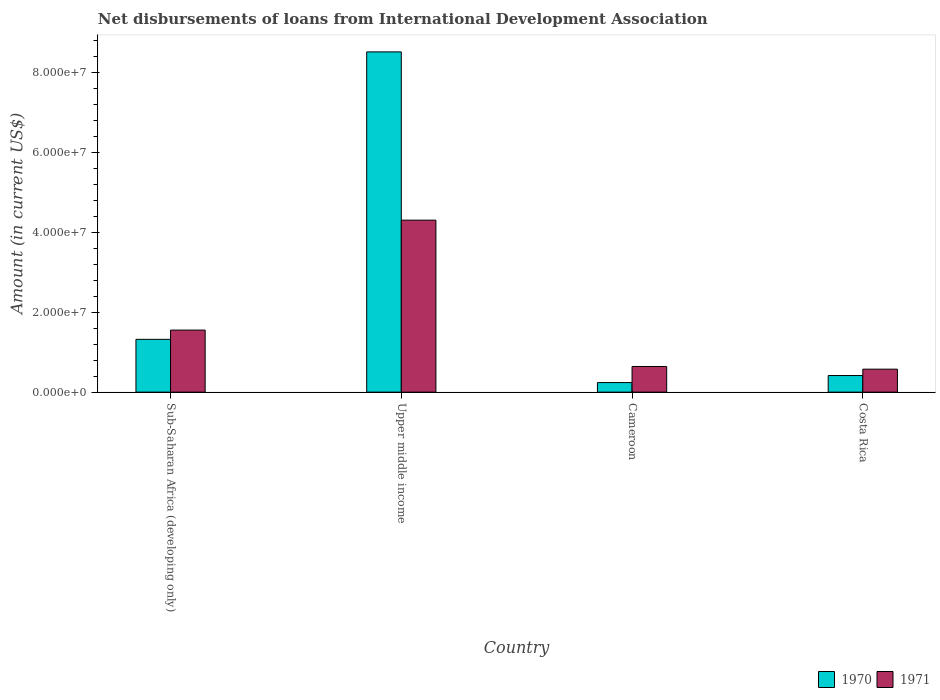How many different coloured bars are there?
Provide a succinct answer. 2. Are the number of bars per tick equal to the number of legend labels?
Your response must be concise. Yes. Are the number of bars on each tick of the X-axis equal?
Ensure brevity in your answer.  Yes. How many bars are there on the 2nd tick from the right?
Give a very brief answer. 2. What is the label of the 1st group of bars from the left?
Provide a succinct answer. Sub-Saharan Africa (developing only). What is the amount of loans disbursed in 1970 in Costa Rica?
Keep it short and to the point. 4.15e+06. Across all countries, what is the maximum amount of loans disbursed in 1971?
Ensure brevity in your answer.  4.30e+07. Across all countries, what is the minimum amount of loans disbursed in 1971?
Offer a very short reply. 5.74e+06. In which country was the amount of loans disbursed in 1971 maximum?
Make the answer very short. Upper middle income. In which country was the amount of loans disbursed in 1970 minimum?
Your response must be concise. Cameroon. What is the total amount of loans disbursed in 1971 in the graph?
Provide a short and direct response. 7.07e+07. What is the difference between the amount of loans disbursed in 1970 in Costa Rica and that in Upper middle income?
Provide a succinct answer. -8.09e+07. What is the difference between the amount of loans disbursed in 1970 in Cameroon and the amount of loans disbursed in 1971 in Sub-Saharan Africa (developing only)?
Your answer should be compact. -1.31e+07. What is the average amount of loans disbursed in 1970 per country?
Offer a very short reply. 2.62e+07. What is the difference between the amount of loans disbursed of/in 1971 and amount of loans disbursed of/in 1970 in Costa Rica?
Provide a short and direct response. 1.59e+06. In how many countries, is the amount of loans disbursed in 1970 greater than 60000000 US$?
Ensure brevity in your answer.  1. What is the ratio of the amount of loans disbursed in 1971 in Cameroon to that in Sub-Saharan Africa (developing only)?
Give a very brief answer. 0.41. What is the difference between the highest and the second highest amount of loans disbursed in 1970?
Give a very brief answer. 7.19e+07. What is the difference between the highest and the lowest amount of loans disbursed in 1970?
Your answer should be very brief. 8.27e+07. Is the sum of the amount of loans disbursed in 1970 in Cameroon and Sub-Saharan Africa (developing only) greater than the maximum amount of loans disbursed in 1971 across all countries?
Make the answer very short. No. What does the 2nd bar from the right in Cameroon represents?
Your answer should be compact. 1970. Where does the legend appear in the graph?
Offer a very short reply. Bottom right. How many legend labels are there?
Keep it short and to the point. 2. What is the title of the graph?
Your answer should be compact. Net disbursements of loans from International Development Association. What is the label or title of the Y-axis?
Provide a succinct answer. Amount (in current US$). What is the Amount (in current US$) of 1970 in Sub-Saharan Africa (developing only)?
Your response must be concise. 1.32e+07. What is the Amount (in current US$) of 1971 in Sub-Saharan Africa (developing only)?
Your answer should be very brief. 1.55e+07. What is the Amount (in current US$) of 1970 in Upper middle income?
Offer a very short reply. 8.51e+07. What is the Amount (in current US$) of 1971 in Upper middle income?
Provide a short and direct response. 4.30e+07. What is the Amount (in current US$) in 1970 in Cameroon?
Offer a terse response. 2.40e+06. What is the Amount (in current US$) of 1971 in Cameroon?
Provide a succinct answer. 6.42e+06. What is the Amount (in current US$) in 1970 in Costa Rica?
Ensure brevity in your answer.  4.15e+06. What is the Amount (in current US$) in 1971 in Costa Rica?
Your answer should be very brief. 5.74e+06. Across all countries, what is the maximum Amount (in current US$) in 1970?
Keep it short and to the point. 8.51e+07. Across all countries, what is the maximum Amount (in current US$) of 1971?
Your response must be concise. 4.30e+07. Across all countries, what is the minimum Amount (in current US$) in 1970?
Make the answer very short. 2.40e+06. Across all countries, what is the minimum Amount (in current US$) in 1971?
Offer a very short reply. 5.74e+06. What is the total Amount (in current US$) of 1970 in the graph?
Make the answer very short. 1.05e+08. What is the total Amount (in current US$) in 1971 in the graph?
Give a very brief answer. 7.07e+07. What is the difference between the Amount (in current US$) in 1970 in Sub-Saharan Africa (developing only) and that in Upper middle income?
Give a very brief answer. -7.19e+07. What is the difference between the Amount (in current US$) of 1971 in Sub-Saharan Africa (developing only) and that in Upper middle income?
Make the answer very short. -2.75e+07. What is the difference between the Amount (in current US$) in 1970 in Sub-Saharan Africa (developing only) and that in Cameroon?
Your response must be concise. 1.08e+07. What is the difference between the Amount (in current US$) of 1971 in Sub-Saharan Africa (developing only) and that in Cameroon?
Your answer should be very brief. 9.10e+06. What is the difference between the Amount (in current US$) in 1970 in Sub-Saharan Africa (developing only) and that in Costa Rica?
Make the answer very short. 9.05e+06. What is the difference between the Amount (in current US$) in 1971 in Sub-Saharan Africa (developing only) and that in Costa Rica?
Provide a succinct answer. 9.77e+06. What is the difference between the Amount (in current US$) in 1970 in Upper middle income and that in Cameroon?
Your answer should be compact. 8.27e+07. What is the difference between the Amount (in current US$) in 1971 in Upper middle income and that in Cameroon?
Your response must be concise. 3.66e+07. What is the difference between the Amount (in current US$) of 1970 in Upper middle income and that in Costa Rica?
Your answer should be very brief. 8.09e+07. What is the difference between the Amount (in current US$) in 1971 in Upper middle income and that in Costa Rica?
Provide a succinct answer. 3.73e+07. What is the difference between the Amount (in current US$) of 1970 in Cameroon and that in Costa Rica?
Provide a succinct answer. -1.76e+06. What is the difference between the Amount (in current US$) of 1971 in Cameroon and that in Costa Rica?
Ensure brevity in your answer.  6.75e+05. What is the difference between the Amount (in current US$) of 1970 in Sub-Saharan Africa (developing only) and the Amount (in current US$) of 1971 in Upper middle income?
Ensure brevity in your answer.  -2.98e+07. What is the difference between the Amount (in current US$) in 1970 in Sub-Saharan Africa (developing only) and the Amount (in current US$) in 1971 in Cameroon?
Your answer should be very brief. 6.78e+06. What is the difference between the Amount (in current US$) of 1970 in Sub-Saharan Africa (developing only) and the Amount (in current US$) of 1971 in Costa Rica?
Offer a very short reply. 7.46e+06. What is the difference between the Amount (in current US$) of 1970 in Upper middle income and the Amount (in current US$) of 1971 in Cameroon?
Your response must be concise. 7.86e+07. What is the difference between the Amount (in current US$) of 1970 in Upper middle income and the Amount (in current US$) of 1971 in Costa Rica?
Offer a terse response. 7.93e+07. What is the difference between the Amount (in current US$) in 1970 in Cameroon and the Amount (in current US$) in 1971 in Costa Rica?
Your response must be concise. -3.35e+06. What is the average Amount (in current US$) in 1970 per country?
Offer a very short reply. 2.62e+07. What is the average Amount (in current US$) in 1971 per country?
Your response must be concise. 1.77e+07. What is the difference between the Amount (in current US$) in 1970 and Amount (in current US$) in 1971 in Sub-Saharan Africa (developing only)?
Ensure brevity in your answer.  -2.31e+06. What is the difference between the Amount (in current US$) of 1970 and Amount (in current US$) of 1971 in Upper middle income?
Keep it short and to the point. 4.21e+07. What is the difference between the Amount (in current US$) of 1970 and Amount (in current US$) of 1971 in Cameroon?
Your answer should be very brief. -4.02e+06. What is the difference between the Amount (in current US$) of 1970 and Amount (in current US$) of 1971 in Costa Rica?
Your answer should be compact. -1.59e+06. What is the ratio of the Amount (in current US$) of 1970 in Sub-Saharan Africa (developing only) to that in Upper middle income?
Your answer should be very brief. 0.16. What is the ratio of the Amount (in current US$) in 1971 in Sub-Saharan Africa (developing only) to that in Upper middle income?
Make the answer very short. 0.36. What is the ratio of the Amount (in current US$) in 1970 in Sub-Saharan Africa (developing only) to that in Cameroon?
Ensure brevity in your answer.  5.51. What is the ratio of the Amount (in current US$) of 1971 in Sub-Saharan Africa (developing only) to that in Cameroon?
Ensure brevity in your answer.  2.42. What is the ratio of the Amount (in current US$) in 1970 in Sub-Saharan Africa (developing only) to that in Costa Rica?
Give a very brief answer. 3.18. What is the ratio of the Amount (in current US$) of 1971 in Sub-Saharan Africa (developing only) to that in Costa Rica?
Provide a succinct answer. 2.7. What is the ratio of the Amount (in current US$) in 1970 in Upper middle income to that in Cameroon?
Offer a very short reply. 35.5. What is the ratio of the Amount (in current US$) of 1971 in Upper middle income to that in Cameroon?
Make the answer very short. 6.7. What is the ratio of the Amount (in current US$) in 1970 in Upper middle income to that in Costa Rica?
Offer a terse response. 20.48. What is the ratio of the Amount (in current US$) in 1971 in Upper middle income to that in Costa Rica?
Offer a very short reply. 7.49. What is the ratio of the Amount (in current US$) of 1970 in Cameroon to that in Costa Rica?
Make the answer very short. 0.58. What is the ratio of the Amount (in current US$) in 1971 in Cameroon to that in Costa Rica?
Offer a terse response. 1.12. What is the difference between the highest and the second highest Amount (in current US$) of 1970?
Your answer should be very brief. 7.19e+07. What is the difference between the highest and the second highest Amount (in current US$) in 1971?
Your answer should be very brief. 2.75e+07. What is the difference between the highest and the lowest Amount (in current US$) in 1970?
Provide a short and direct response. 8.27e+07. What is the difference between the highest and the lowest Amount (in current US$) of 1971?
Your answer should be very brief. 3.73e+07. 